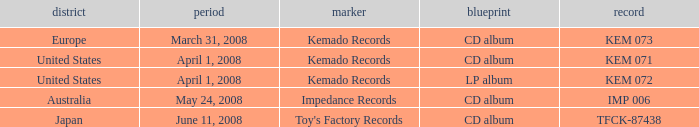Can you parse all the data within this table? {'header': ['district', 'period', 'marker', 'blueprint', 'record'], 'rows': [['Europe', 'March 31, 2008', 'Kemado Records', 'CD album', 'KEM 073'], ['United States', 'April 1, 2008', 'Kemado Records', 'CD album', 'KEM 071'], ['United States', 'April 1, 2008', 'Kemado Records', 'LP album', 'KEM 072'], ['Australia', 'May 24, 2008', 'Impedance Records', 'CD album', 'IMP 006'], ['Japan', 'June 11, 2008', "Toy's Factory Records", 'CD album', 'TFCK-87438']]} Which Region has a Format of cd album, and a Label of kemado records, and a Catalog of kem 071? United States. 